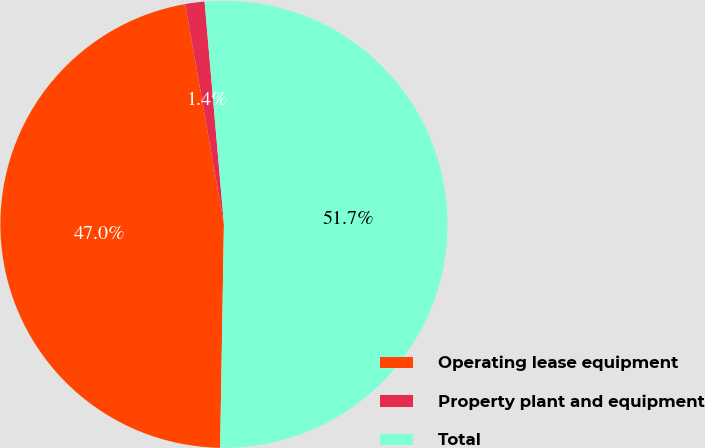Convert chart to OTSL. <chart><loc_0><loc_0><loc_500><loc_500><pie_chart><fcel>Operating lease equipment<fcel>Property plant and equipment<fcel>Total<nl><fcel>46.96%<fcel>1.39%<fcel>51.65%<nl></chart> 